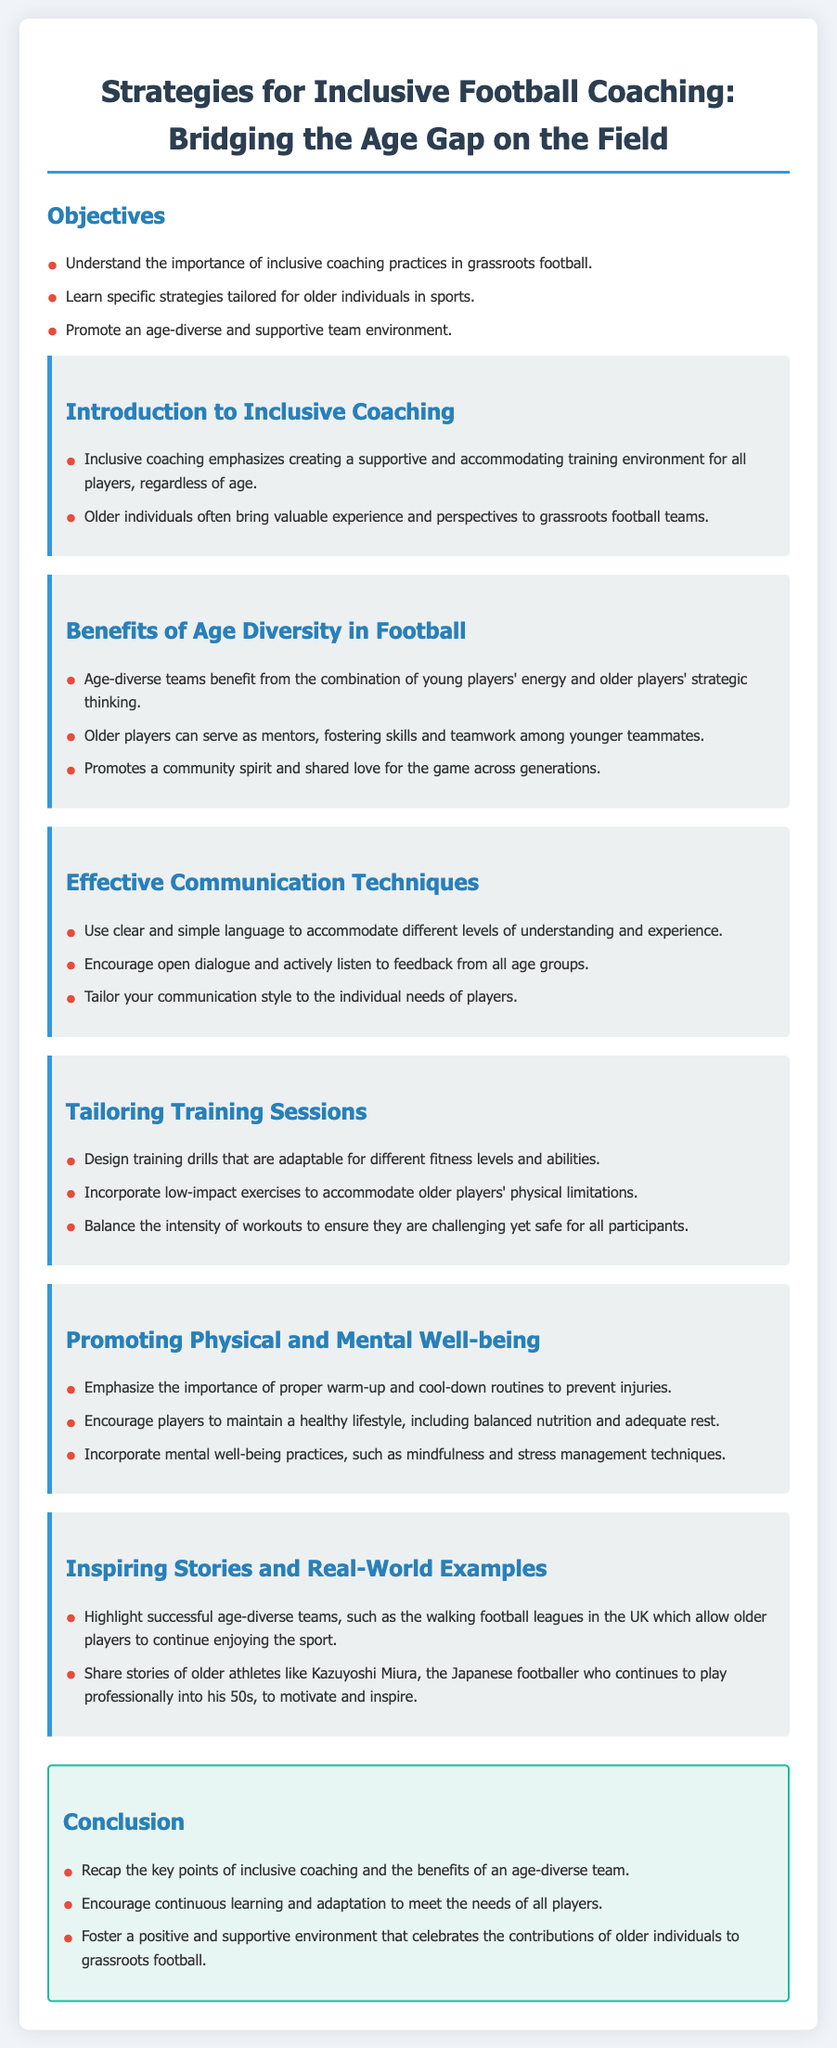what is the title of the lesson plan? The title is found at the top of the document, summarizing its focus on football coaching.
Answer: Strategies for Inclusive Football Coaching: Bridging the Age Gap how many objectives are listed in the lesson plan? The number of objectives is stated in the list under the objectives section.
Answer: three what is one benefit of age diversity in football? The benefits section highlights several advantages, and this answer reflects one of them.
Answer: Strategic thinking what effective communication technique is mentioned? The document lists specific techniques under the effective communication section.
Answer: Clear and simple language what is one way to tailor training sessions? The tailoring training sessions section provides a suggestion for adapting drills.
Answer: Adaptable for different fitness levels who is Kazuyoshi Miura? This individual is mentioned as an inspirational figure in the stories and examples section.
Answer: A Japanese footballer what is emphasized regarding players' health? The document highlights the importance of routines and lifestyle in relation to well-being.
Answer: Proper warm-up and cool-down routines what is the purpose of the conclusion section? The conclusion summarizes the main points and encourages continued efforts in coaching practices.
Answer: Recap the key points how does the lesson plan encourage a positive environment? The conclusion suggests fostering a supportive atmosphere for older individuals.
Answer: Celebrate the contributions of older individuals 